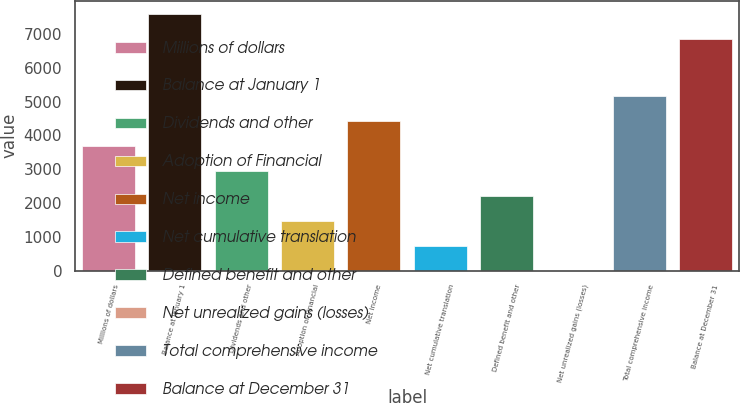Convert chart to OTSL. <chart><loc_0><loc_0><loc_500><loc_500><bar_chart><fcel>Millions of dollars<fcel>Balance at January 1<fcel>Dividends and other<fcel>Adoption of Financial<fcel>Net income<fcel>Net cumulative translation<fcel>Defined benefit and other<fcel>Net unrealized gains (losses)<fcel>Total comprehensive income<fcel>Balance at December 31<nl><fcel>3688.5<fcel>7603.5<fcel>2951<fcel>1476<fcel>4426<fcel>738.5<fcel>2213.5<fcel>1<fcel>5163.5<fcel>6866<nl></chart> 